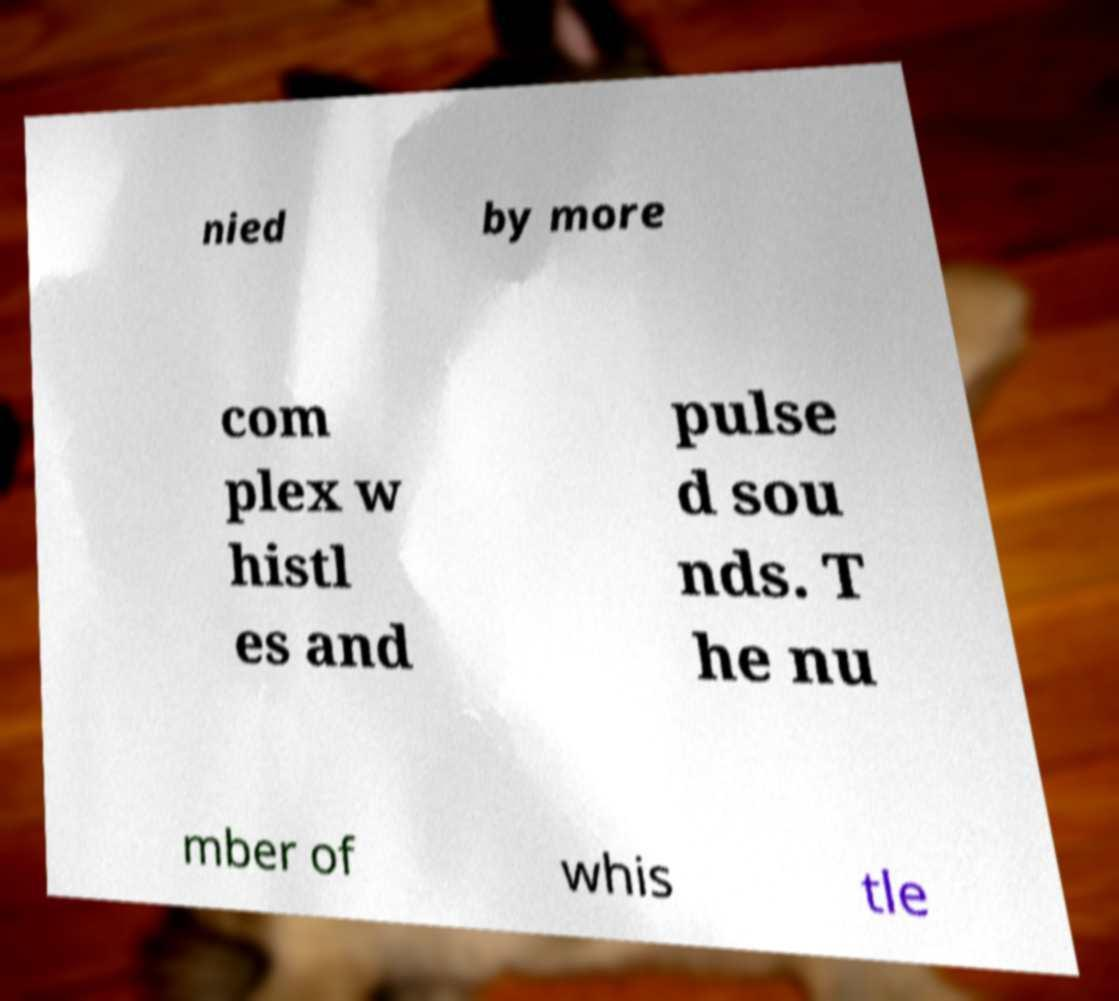Could you extract and type out the text from this image? nied by more com plex w histl es and pulse d sou nds. T he nu mber of whis tle 